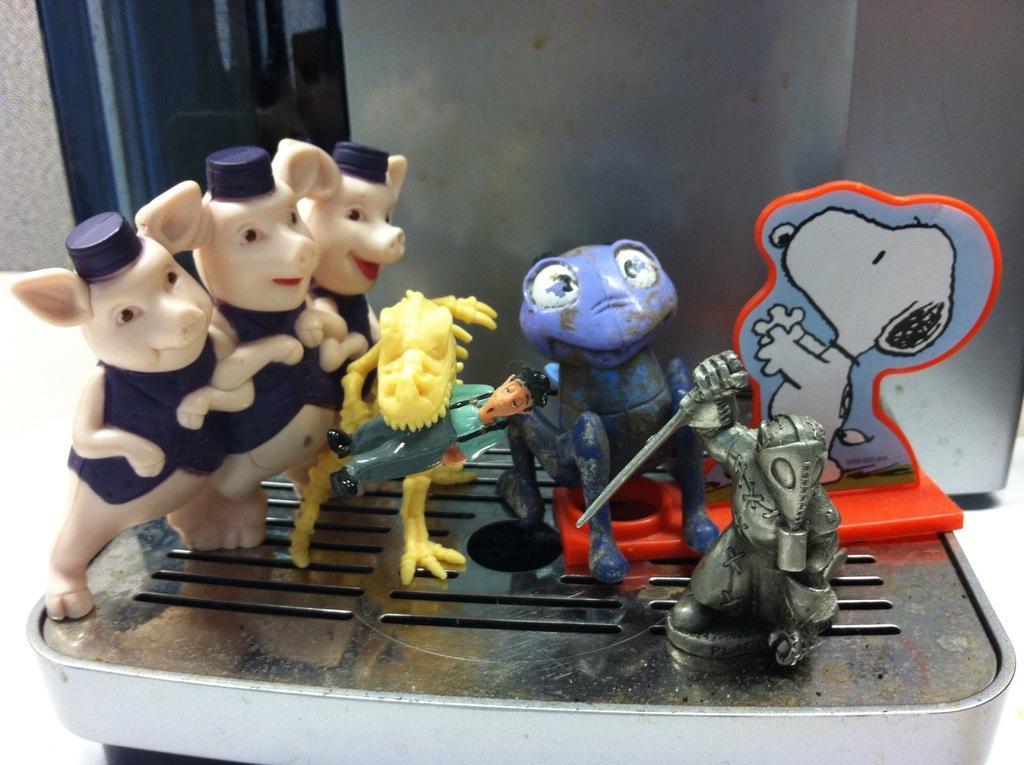In one or two sentences, can you explain what this image depicts? This picture shows few toys on the machine, It is on the table and we see a window to the wall. 